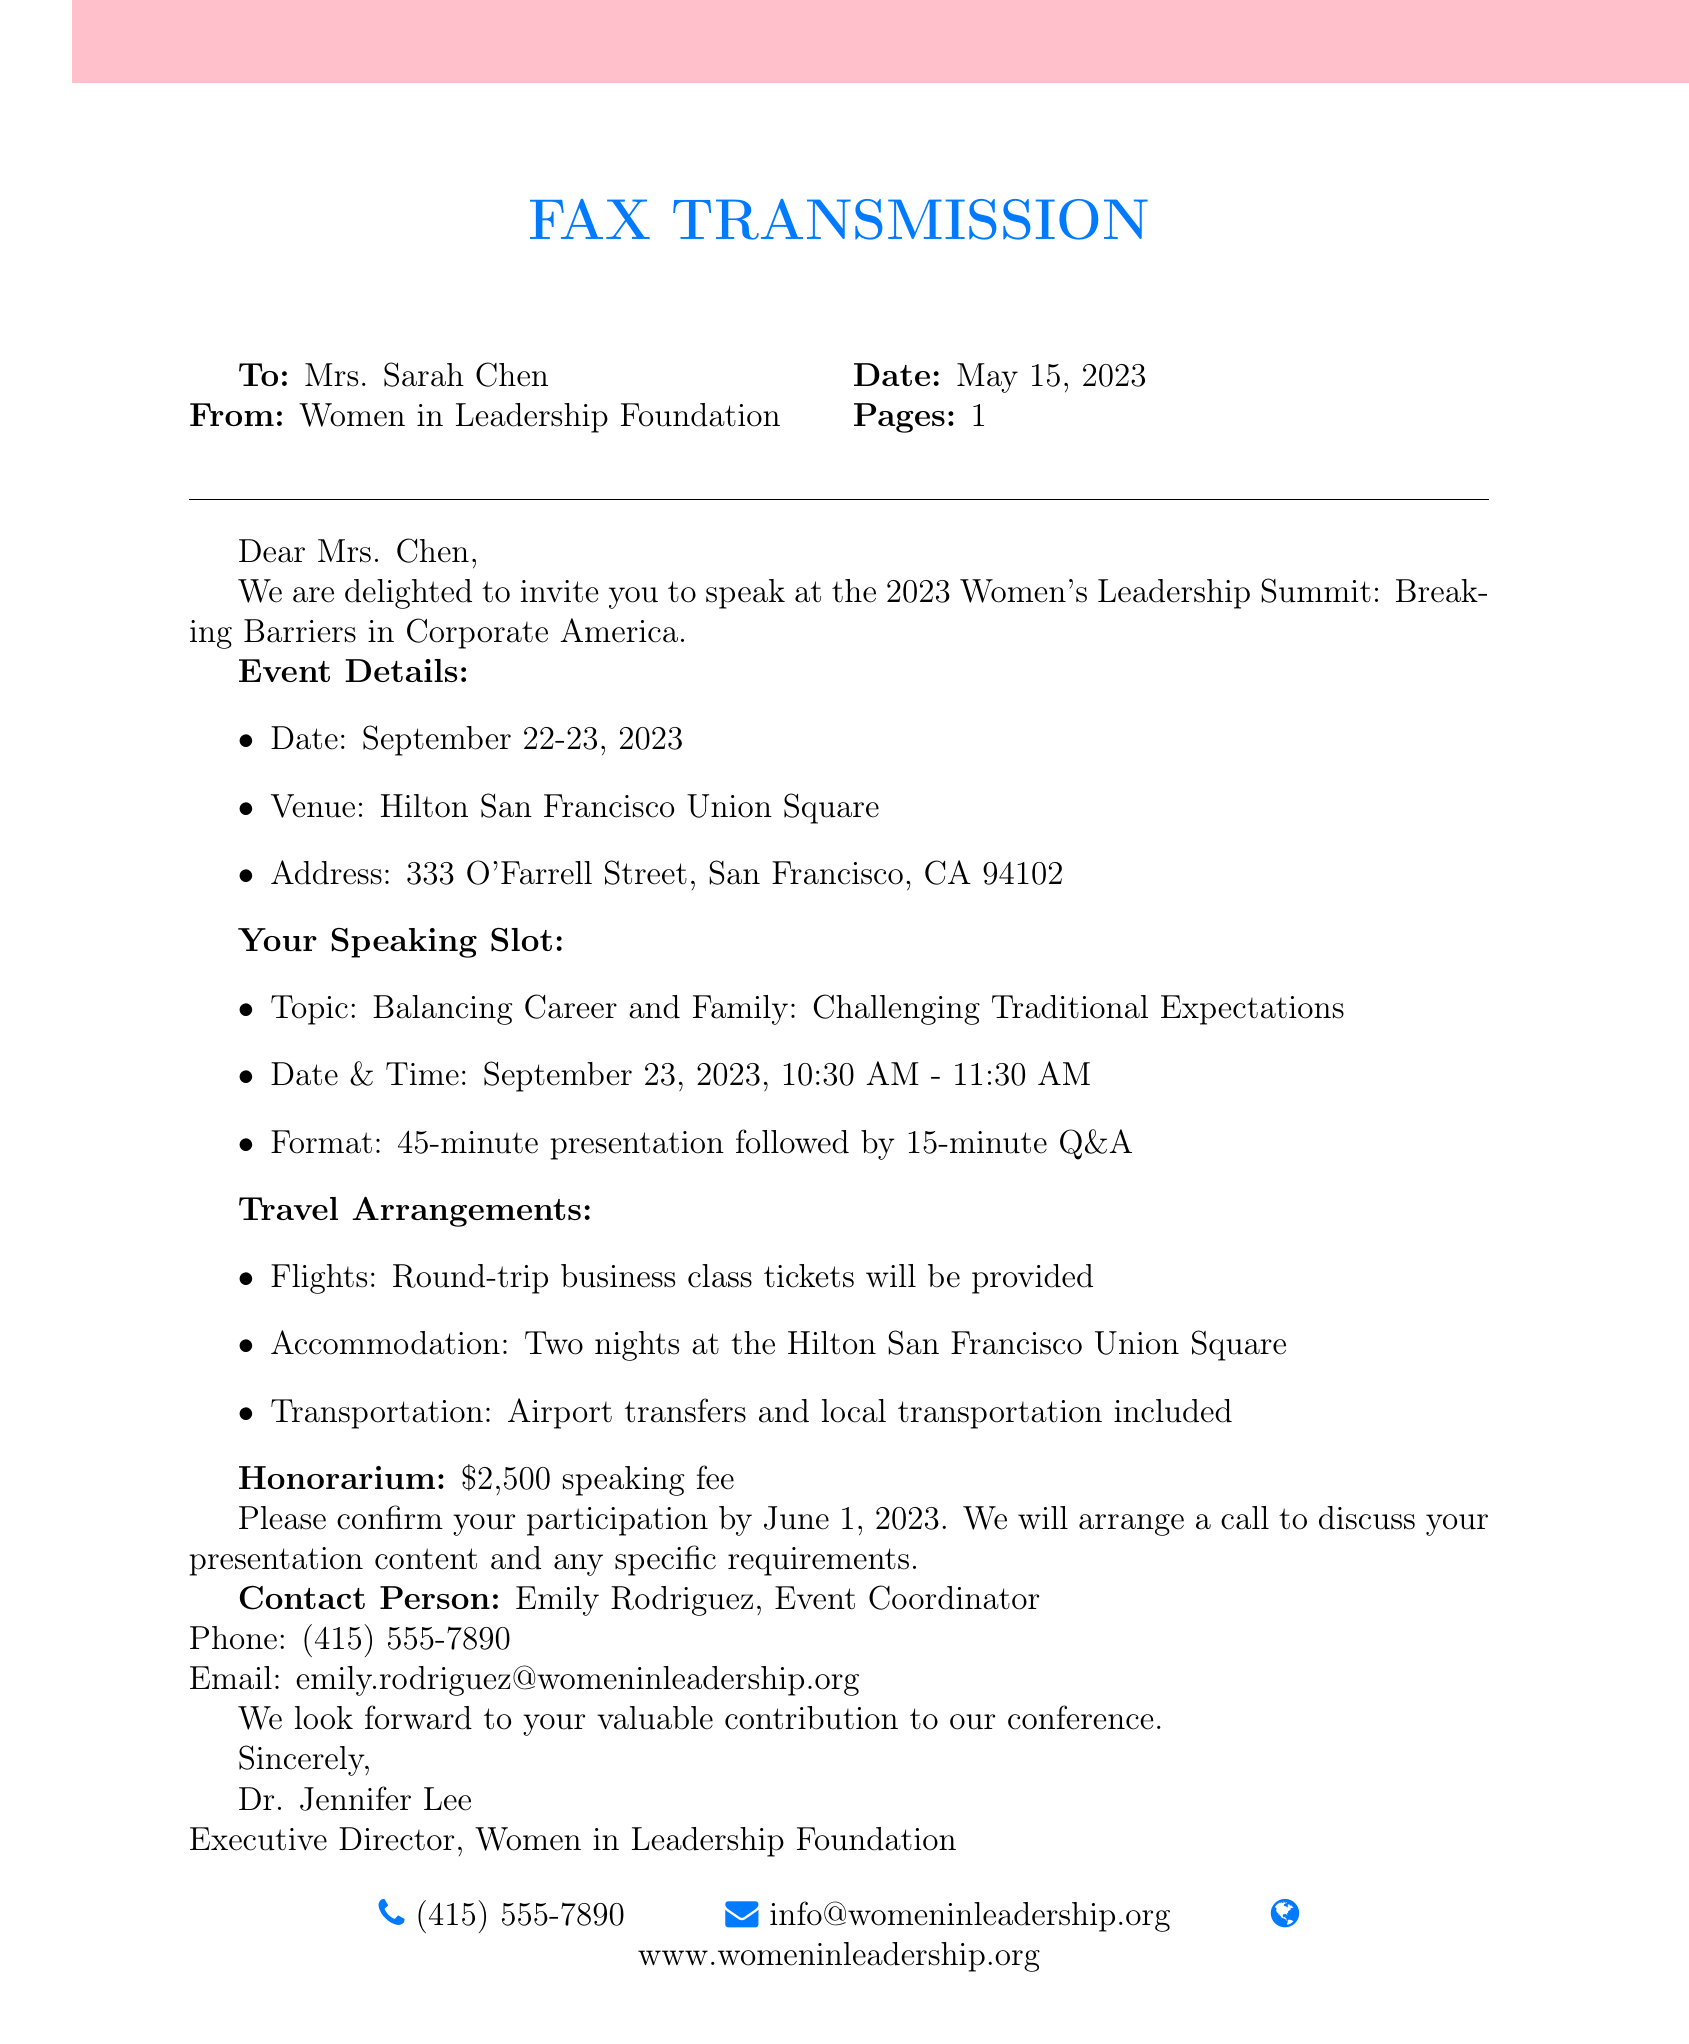What is the name of the event? The document states that the event is the "2023 Women's Leadership Summit: Breaking Barriers in Corporate America."
Answer: 2023 Women's Leadership Summit: Breaking Barriers in Corporate America What are the dates of the event? The event is scheduled for September 22-23, 2023, as mentioned in the event details.
Answer: September 22-23, 2023 Who is the contact person for the event? The document identifies Emily Rodriguez as the contact person for the conference.
Answer: Emily Rodriguez What is the honorarium offered? The document specifies that the speaking fee is $2,500.
Answer: $2,500 What time is Mrs. Chen's speaking slot? The speaking slot for Mrs. Chen is from 10:30 AM to 11:30 AM on September 23, 2023.
Answer: 10:30 AM - 11:30 AM How long will the presentation last? The document states that the presentation will last for 45 minutes followed by a 15-minute Q&A.
Answer: 45 minutes What type of accommodation will be provided? The document mentions two nights at the Hilton San Francisco Union Square for accommodation.
Answer: Two nights at the Hilton San Francisco Union Square What will be covered in the travel arrangements? The travel arrangements include round-trip business class tickets, airport transfers, and local transportation.
Answer: Round-trip business class tickets, airport transfers, local transportation What is the topic of Mrs. Chen's presentation? The topic of the presentation is "Balancing Career and Family: Challenging Traditional Expectations."
Answer: Balancing Career and Family: Challenging Traditional Expectations 